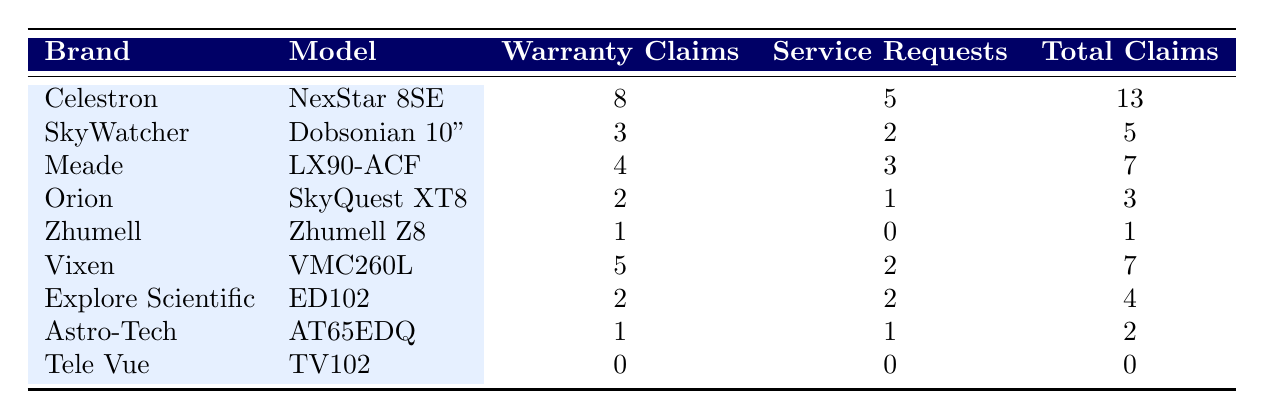What is the total number of warranty claims for the Celestron NexStar 8SE? In the table, under the column for Warranty Claims, the value associated with Celestron NexStar 8SE is 8.
Answer: 8 Which telescope model has the highest total claims? To find this, look at the Total Claims column and identify the highest value. The Celestron NexStar 8SE has 13 total claims, which is the highest when compared to other models.
Answer: Celestron NexStar 8SE How many service requests did the Orion SkyQuest XT8 receive? Referring to the Service Requests column, the Orion SkyQuest XT8 shows a value of 1.
Answer: 1 What is the average number of warranty claims across all telescope models? First, sum all the warranty claims: 8 + 3 + 4 + 2 + 1 + 5 + 2 + 1 + 0 = 26. Then, divide by the number of models, which is 9. The average is 26/9 ≈ 2.89.
Answer: Approximately 2.89 Is it true that Tele Vue models have received any warranty claims or service requests? Checking both the Warranty Claims and Service Requests columns for the Tele Vue TV102, both values are 0, indicating no claims or requests.
Answer: Yes, it is true 